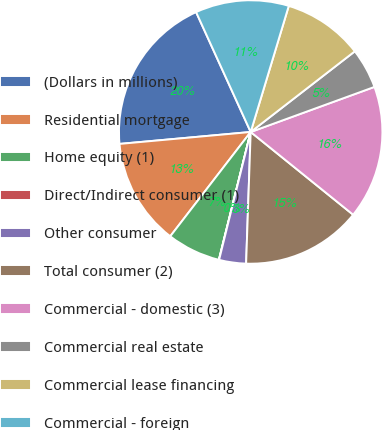Convert chart. <chart><loc_0><loc_0><loc_500><loc_500><pie_chart><fcel>(Dollars in millions)<fcel>Residential mortgage<fcel>Home equity (1)<fcel>Direct/Indirect consumer (1)<fcel>Other consumer<fcel>Total consumer (2)<fcel>Commercial - domestic (3)<fcel>Commercial real estate<fcel>Commercial lease financing<fcel>Commercial - foreign<nl><fcel>19.64%<fcel>13.1%<fcel>6.57%<fcel>0.03%<fcel>3.3%<fcel>14.74%<fcel>16.37%<fcel>4.93%<fcel>9.84%<fcel>11.47%<nl></chart> 